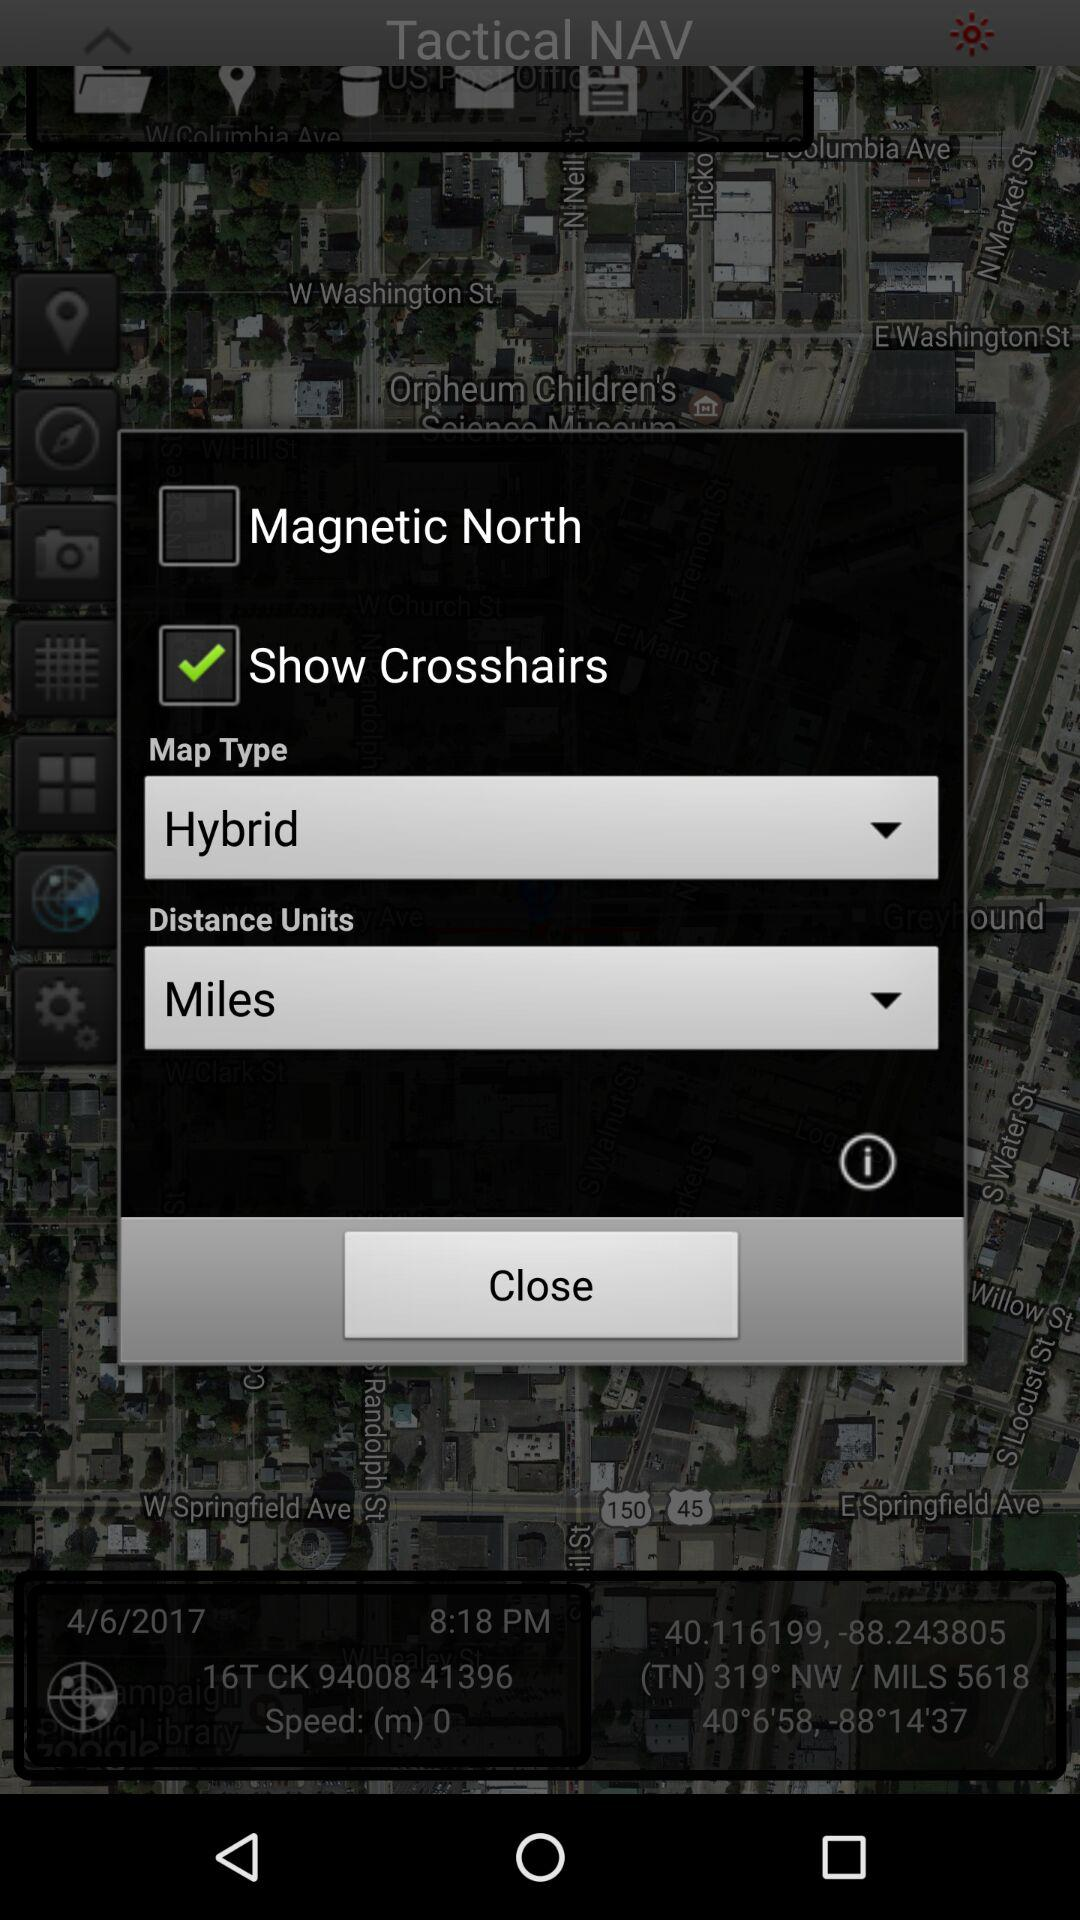What is the name of the application? The name of the application is "Tactical NAV". 